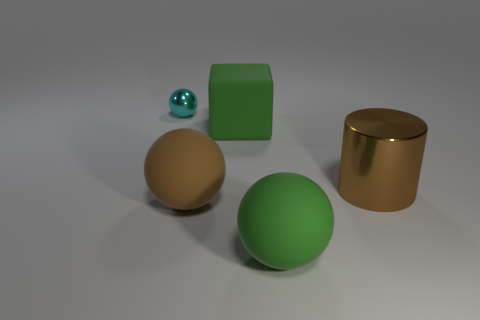Add 1 large matte cubes. How many objects exist? 6 Subtract all big green matte spheres. How many spheres are left? 2 Subtract 1 spheres. How many spheres are left? 2 Subtract all cylinders. How many objects are left? 4 Add 1 brown cylinders. How many brown cylinders exist? 2 Subtract 1 green spheres. How many objects are left? 4 Subtract all cyan spheres. Subtract all purple cylinders. How many spheres are left? 2 Subtract all tiny blue matte cubes. Subtract all big green matte things. How many objects are left? 3 Add 2 big brown objects. How many big brown objects are left? 4 